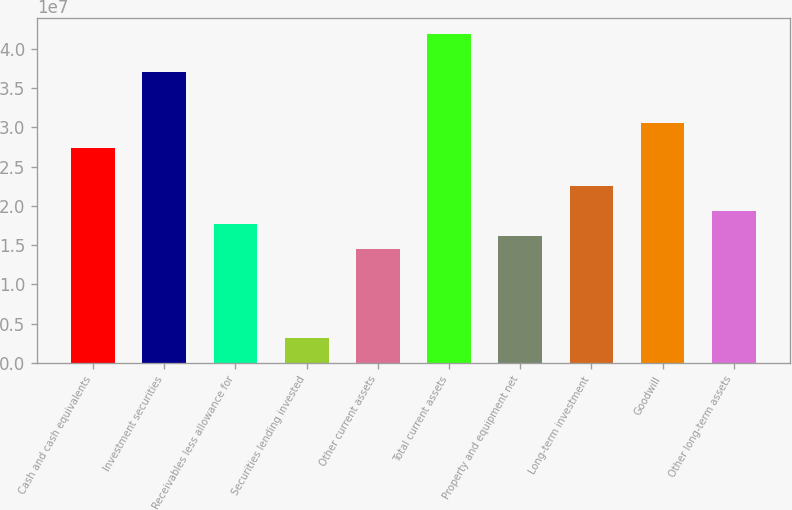Convert chart to OTSL. <chart><loc_0><loc_0><loc_500><loc_500><bar_chart><fcel>Cash and cash equivalents<fcel>Investment securities<fcel>Receivables less allowance for<fcel>Securities lending invested<fcel>Other current assets<fcel>Total current assets<fcel>Property and equipment net<fcel>Long-term investment<fcel>Goodwill<fcel>Other long-term assets<nl><fcel>2.73755e+07<fcel>3.70375e+07<fcel>1.77136e+07<fcel>3.22065e+06<fcel>1.44929e+07<fcel>4.18685e+07<fcel>1.61033e+07<fcel>2.25446e+07<fcel>3.05962e+07<fcel>1.93239e+07<nl></chart> 